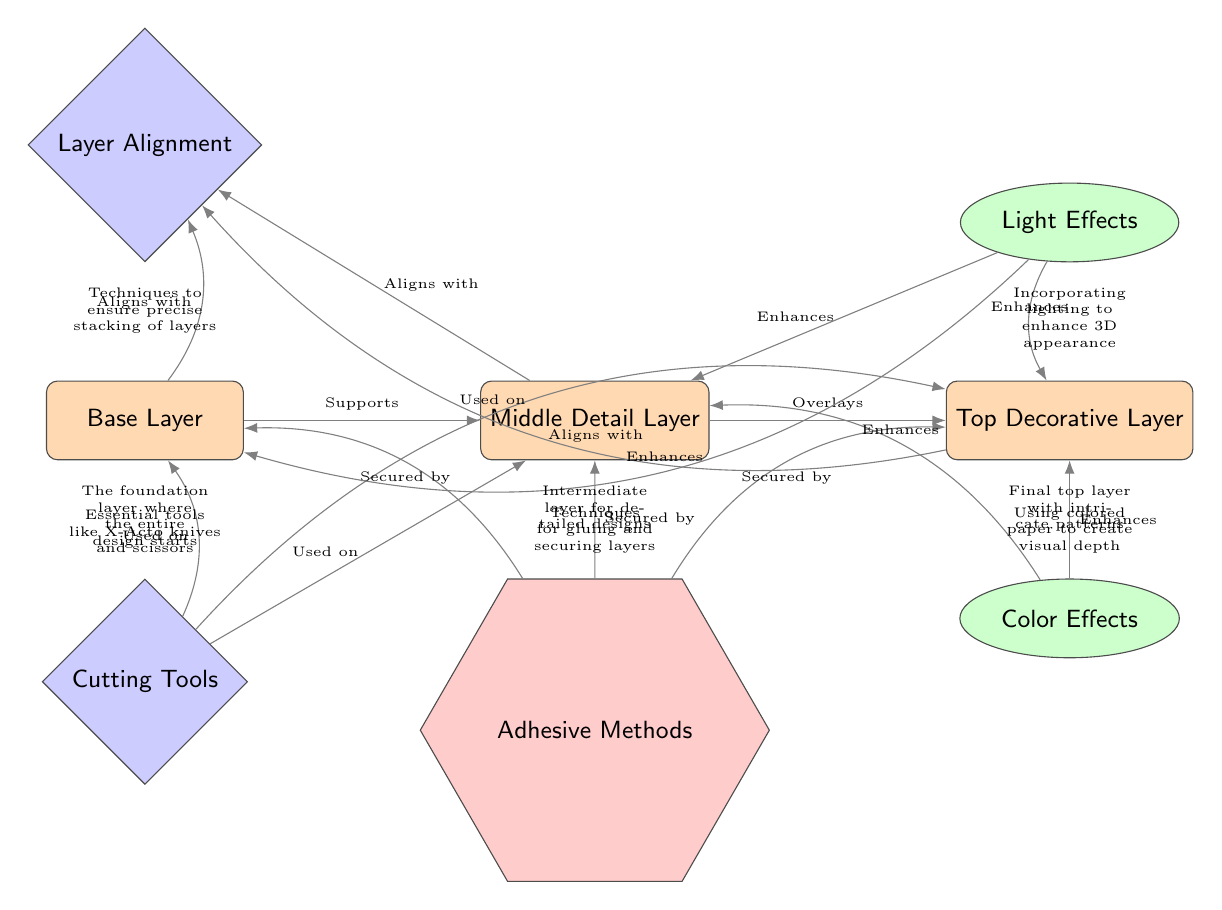What's the top layer in the diagram? The diagram labels the top layer as "Top Decorative Layer," which is indicated clearly in the visual representation of the nodes.
Answer: Top Decorative Layer How many layers are depicted in the diagram? The diagram shows three distinct layers: Base Layer, Middle Detail Layer, and Top Decorative Layer, which can be counted by looking at the layer nodes.
Answer: 3 What tool is used on the Base Layer? The diagram shows "Cutting Tools" as a tool used on the Base Layer, indicated by the edge connecting the base layer to the cutting tools node.
Answer: Cutting Tools Which effect enhances the Mid Layer? According to the diagram, the "Light Effects" node has a direct edge to the Mid Layer, indicating that it enhances the Mid Layer.
Answer: Light Effects What method secures the Top Decorative Layer? The diagram states that the "Adhesive Methods" node secures the Top Decorative Layer, as evidenced by the connection between these two nodes.
Answer: Adhesive Methods How does the Base Layer align with other layers? The Base Layer aligns with the Alignment node, which is indicated by the edge connecting it to the alignment node. Additionally, it connects to the other layers above it in the diagram.
Answer: Aligns with Alignment What enhances both the Top and Middle Layers? "Color Effects" enhances both the Top and Middle Layers, as shown by the edges leading to these layers from the color effects node in the diagram.
Answer: Color Effects Which tools are essential in the papercut art process? "Cutting Tools" is an essential tool noted in the diagram, placed directly above the Base Layer.
Answer: Cutting Tools What is the purpose of the Base Layer in papercut art? The diagram explains that the Base Layer serves as the foundation where the entire design starts, as described in the text below the Base Layer node.
Answer: The foundation layer where the entire design starts 